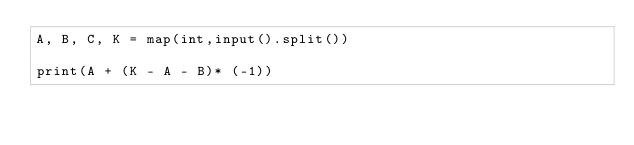Convert code to text. <code><loc_0><loc_0><loc_500><loc_500><_Python_>A, B, C, K = map(int,input().split())

print(A + (K - A - B)* (-1))
</code> 